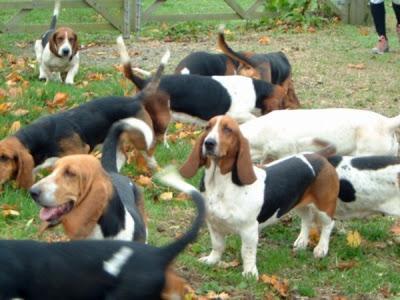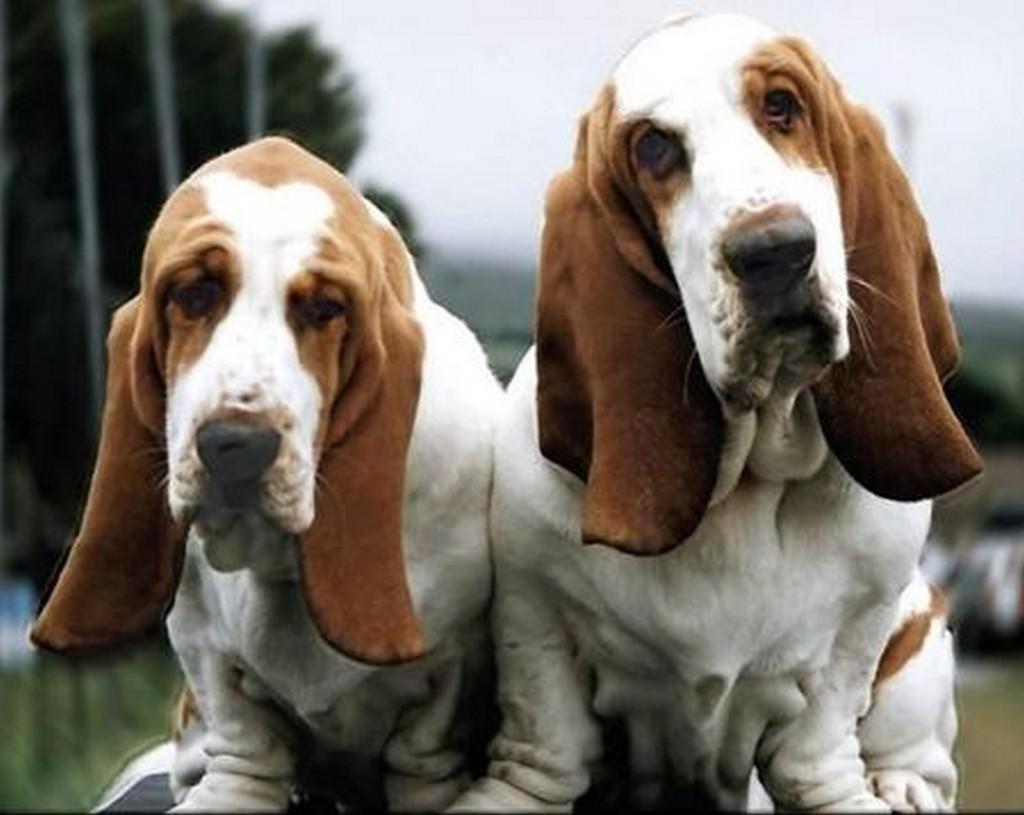The first image is the image on the left, the second image is the image on the right. Examine the images to the left and right. Is the description "Two basset hounds face the camera and are not standing on grass." accurate? Answer yes or no. Yes. The first image is the image on the left, the second image is the image on the right. Considering the images on both sides, is "At least one dog is standing on grass." valid? Answer yes or no. Yes. 